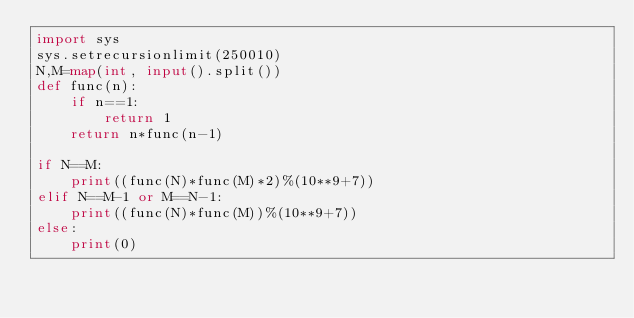Convert code to text. <code><loc_0><loc_0><loc_500><loc_500><_Python_>import sys
sys.setrecursionlimit(250010)
N,M=map(int, input().split())
def func(n):
    if n==1:
        return 1
    return n*func(n-1)

if N==M:
    print((func(N)*func(M)*2)%(10**9+7))
elif N==M-1 or M==N-1:
    print((func(N)*func(M))%(10**9+7))
else:
    print(0)
</code> 